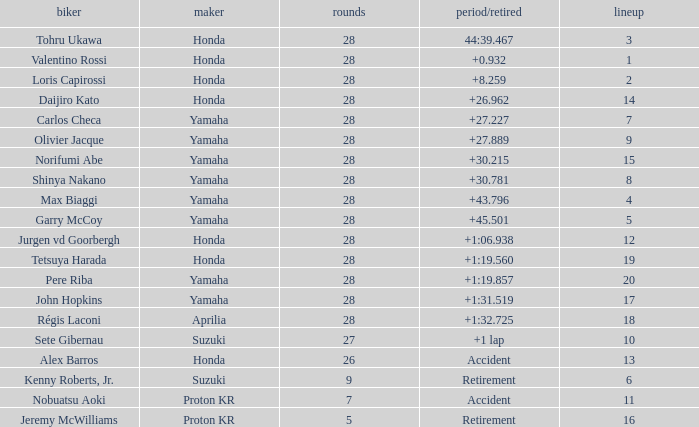Parse the full table. {'header': ['biker', 'maker', 'rounds', 'period/retired', 'lineup'], 'rows': [['Tohru Ukawa', 'Honda', '28', '44:39.467', '3'], ['Valentino Rossi', 'Honda', '28', '+0.932', '1'], ['Loris Capirossi', 'Honda', '28', '+8.259', '2'], ['Daijiro Kato', 'Honda', '28', '+26.962', '14'], ['Carlos Checa', 'Yamaha', '28', '+27.227', '7'], ['Olivier Jacque', 'Yamaha', '28', '+27.889', '9'], ['Norifumi Abe', 'Yamaha', '28', '+30.215', '15'], ['Shinya Nakano', 'Yamaha', '28', '+30.781', '8'], ['Max Biaggi', 'Yamaha', '28', '+43.796', '4'], ['Garry McCoy', 'Yamaha', '28', '+45.501', '5'], ['Jurgen vd Goorbergh', 'Honda', '28', '+1:06.938', '12'], ['Tetsuya Harada', 'Honda', '28', '+1:19.560', '19'], ['Pere Riba', 'Yamaha', '28', '+1:19.857', '20'], ['John Hopkins', 'Yamaha', '28', '+1:31.519', '17'], ['Régis Laconi', 'Aprilia', '28', '+1:32.725', '18'], ['Sete Gibernau', 'Suzuki', '27', '+1 lap', '10'], ['Alex Barros', 'Honda', '26', 'Accident', '13'], ['Kenny Roberts, Jr.', 'Suzuki', '9', 'Retirement', '6'], ['Nobuatsu Aoki', 'Proton KR', '7', 'Accident', '11'], ['Jeremy McWilliams', 'Proton KR', '5', 'Retirement', '16']]} Which Grid has Laps larger than 26, and a Time/Retired of 44:39.467? 3.0. 